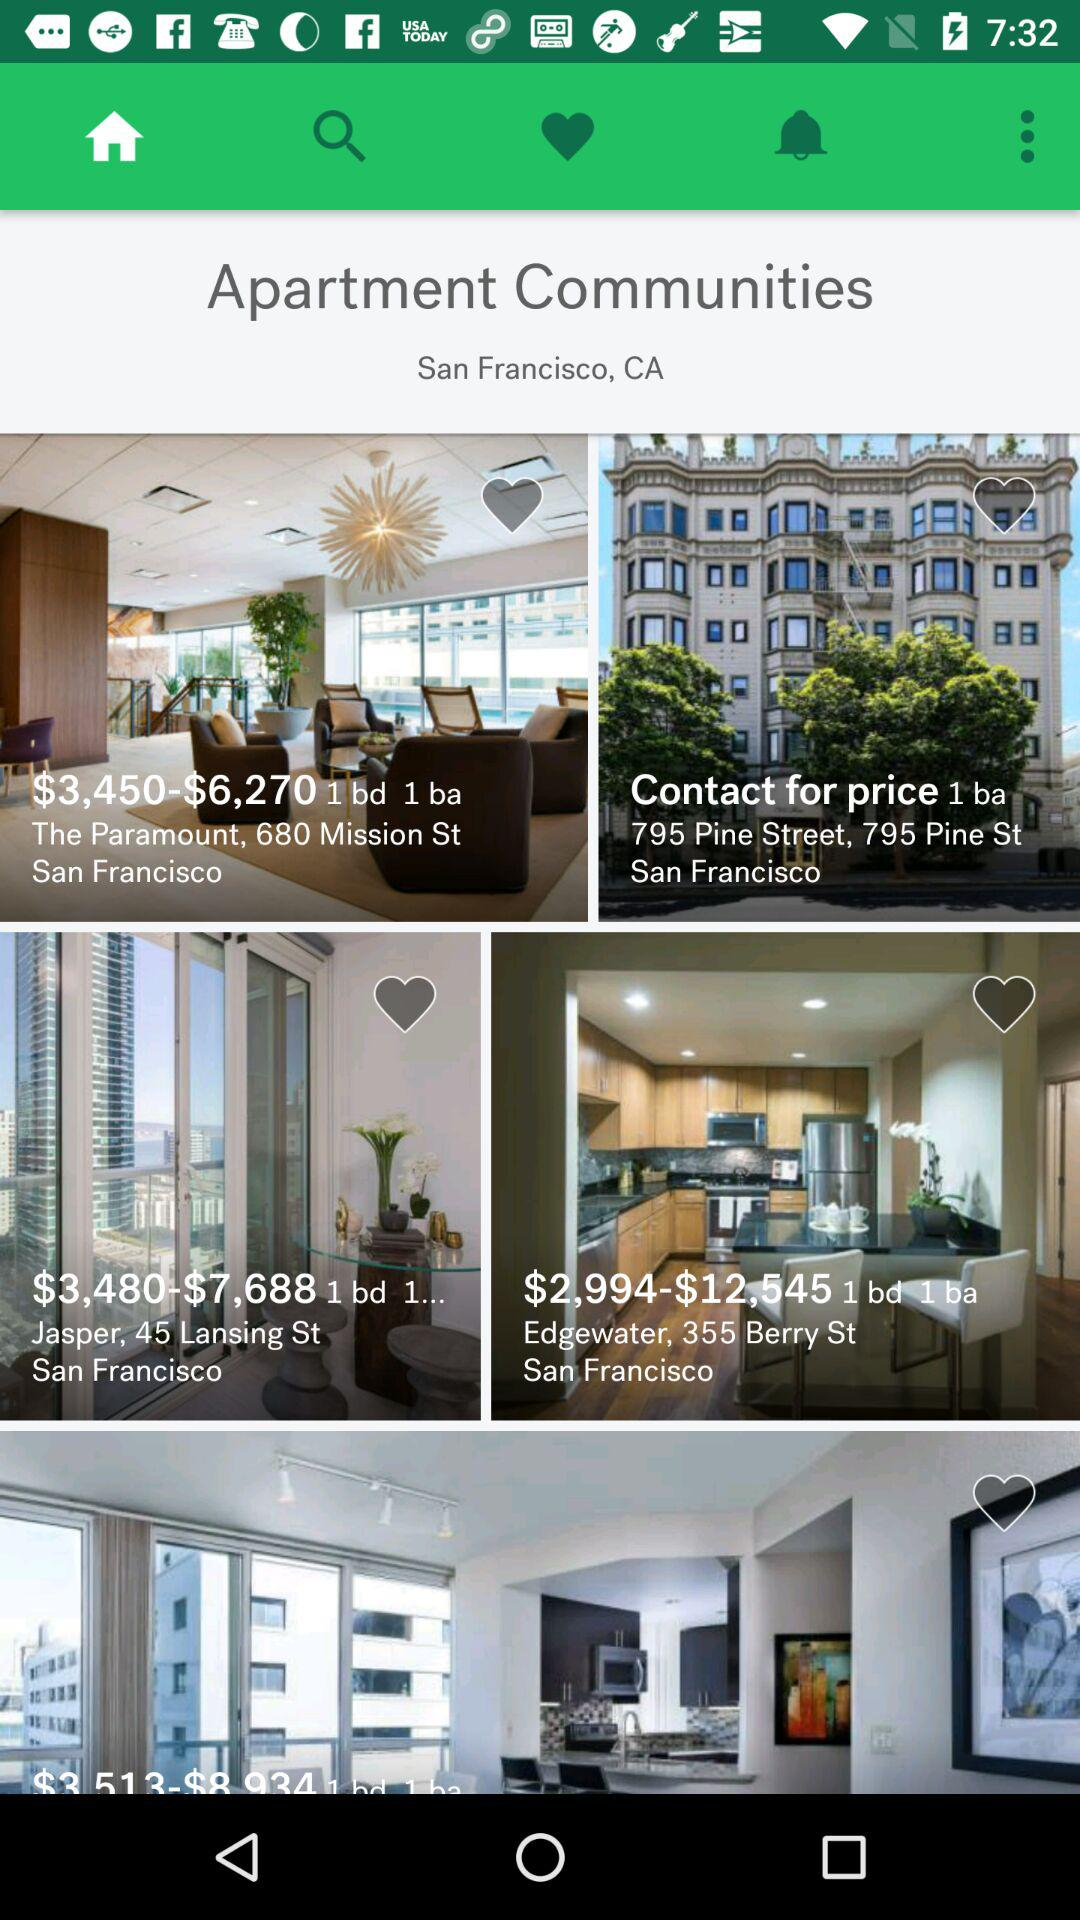What is the price range for "The Paramount, 680 Mission"? The price range for "The Paramount, 680 Mission" is from $3,450 to $6,270. 